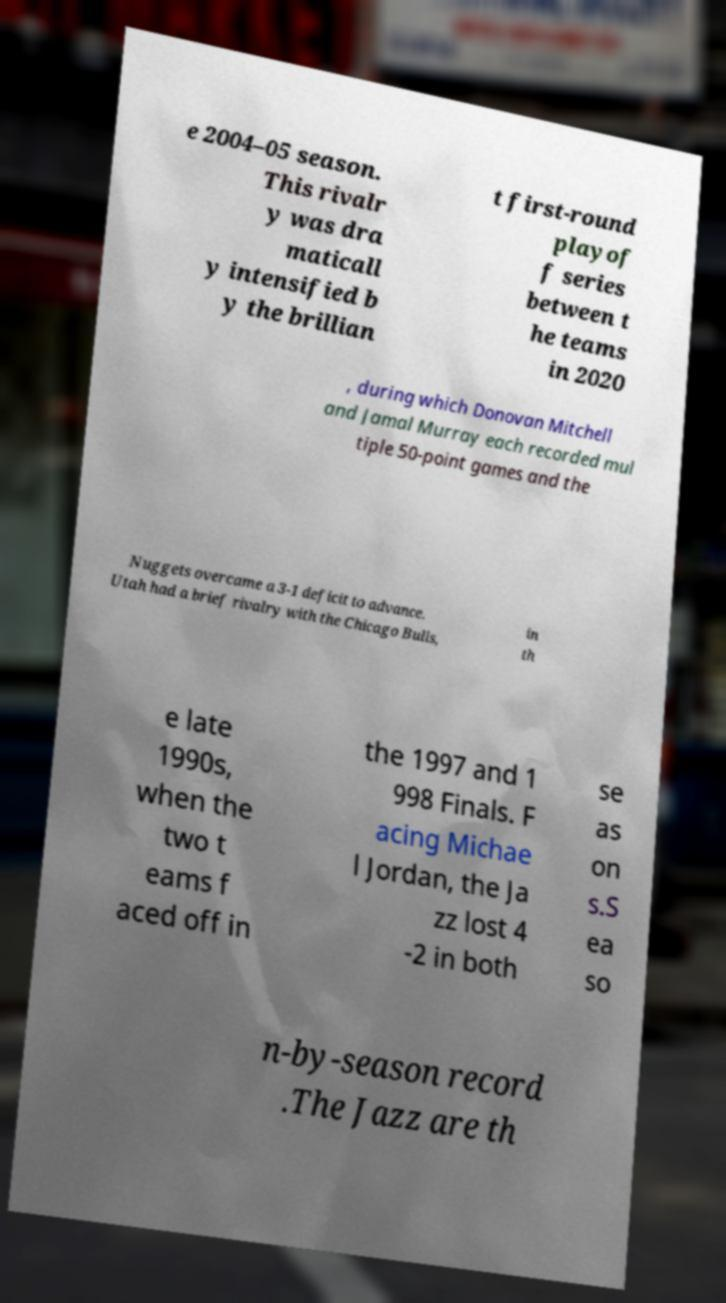Could you assist in decoding the text presented in this image and type it out clearly? e 2004–05 season. This rivalr y was dra maticall y intensified b y the brillian t first-round playof f series between t he teams in 2020 , during which Donovan Mitchell and Jamal Murray each recorded mul tiple 50-point games and the Nuggets overcame a 3-1 deficit to advance. Utah had a brief rivalry with the Chicago Bulls, in th e late 1990s, when the two t eams f aced off in the 1997 and 1 998 Finals. F acing Michae l Jordan, the Ja zz lost 4 -2 in both se as on s.S ea so n-by-season record .The Jazz are th 